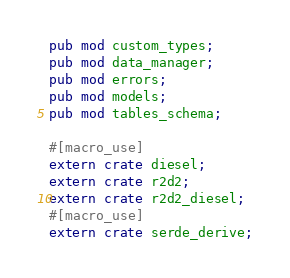<code> <loc_0><loc_0><loc_500><loc_500><_Rust_>pub mod custom_types;
pub mod data_manager;
pub mod errors;
pub mod models;
pub mod tables_schema;

#[macro_use]
extern crate diesel;
extern crate r2d2;
extern crate r2d2_diesel;
#[macro_use]
extern crate serde_derive;</code> 